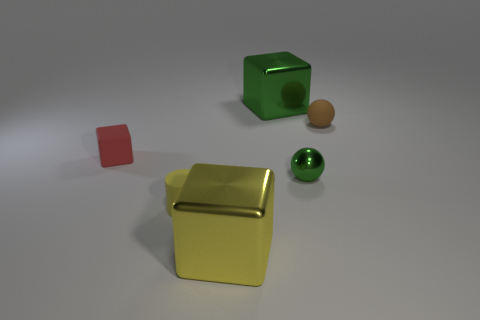Subtract all shiny cubes. How many cubes are left? 1 Add 2 green shiny spheres. How many objects exist? 8 Subtract all spheres. How many objects are left? 4 Subtract 1 blocks. How many blocks are left? 2 Subtract all blue cylinders. How many cyan balls are left? 0 Subtract all small brown matte objects. Subtract all tiny shiny objects. How many objects are left? 4 Add 4 large metallic things. How many large metallic things are left? 6 Add 1 big gray matte objects. How many big gray matte objects exist? 1 Subtract all yellow cubes. How many cubes are left? 2 Subtract 0 yellow balls. How many objects are left? 6 